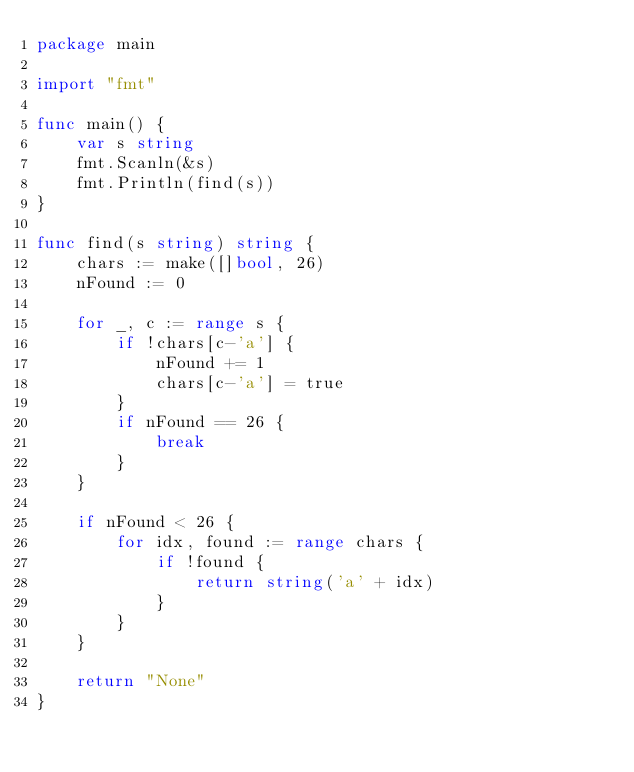<code> <loc_0><loc_0><loc_500><loc_500><_Go_>package main

import "fmt"

func main() {
	var s string
	fmt.Scanln(&s)
	fmt.Println(find(s))
}

func find(s string) string {
	chars := make([]bool, 26)
	nFound := 0

	for _, c := range s {
		if !chars[c-'a'] {
			nFound += 1
			chars[c-'a'] = true
		}
		if nFound == 26 {
			break
		}
	}

	if nFound < 26 {
		for idx, found := range chars {
			if !found {
				return string('a' + idx)
			}
		}
	}

	return "None"
}</code> 